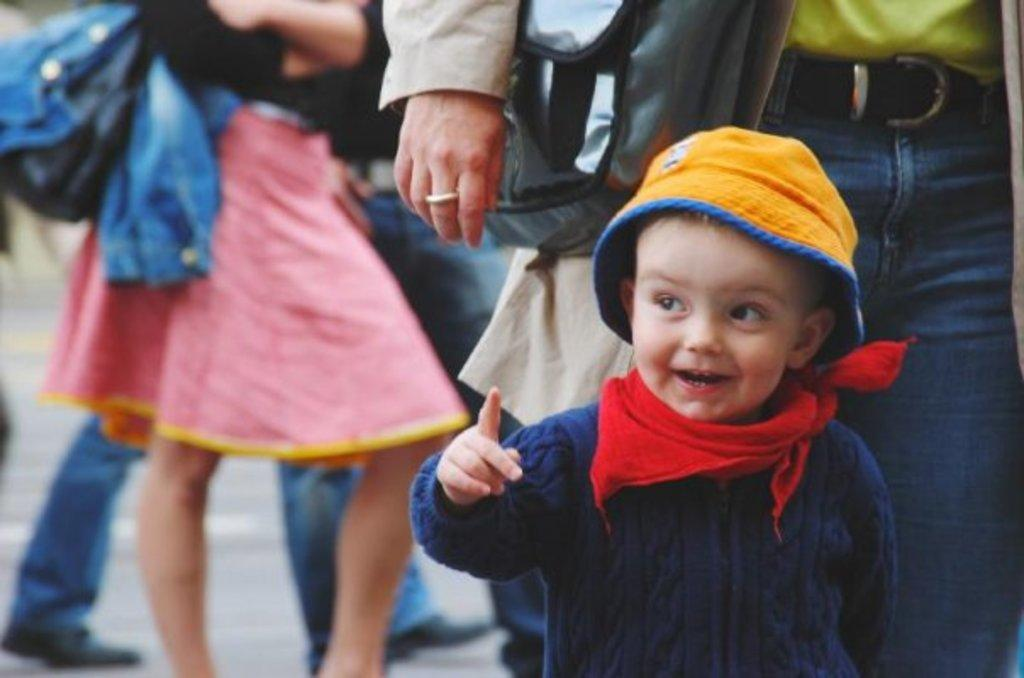What is the main subject of the image? The main subject of the image is a group of people. Can you describe the kid in the image? The kid is on the right side of the image and is smiling. What is the kid wearing? The kid is wearing a cap. What theory does the kid have about the existence of pleasure in the image? There is no indication in the image that the kid has a theory about the existence of pleasure. 